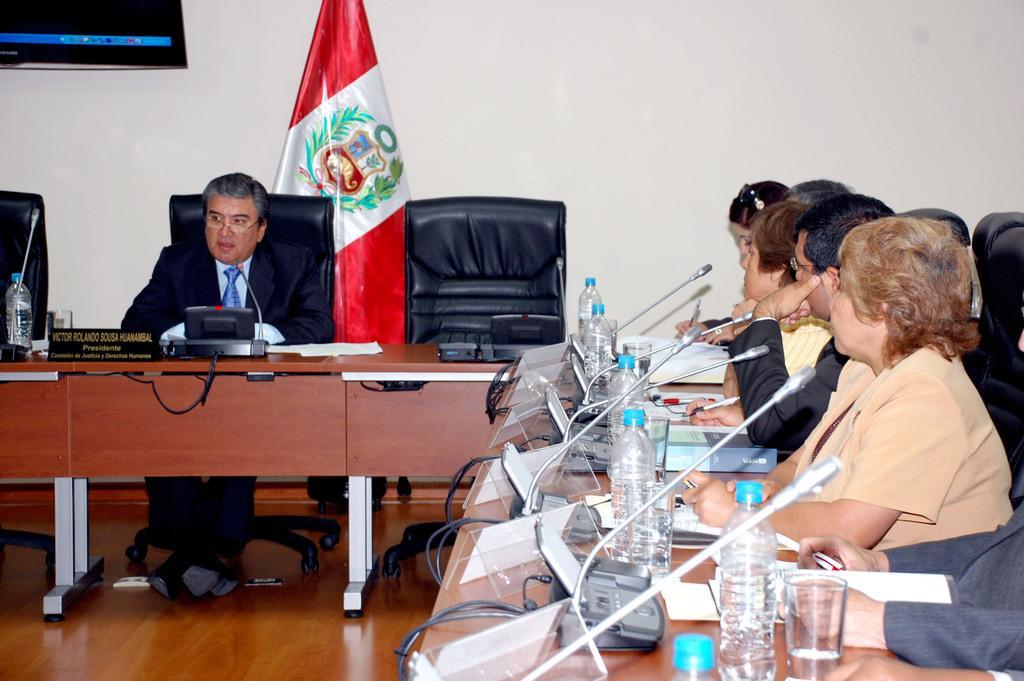Can you describe this image briefly? In this picture we can see some people are sitting on the chair in front of them there is a table on the table we can see microphones water bottles glasses and papers and the left side we can see a table on the table we have microphone water bottle and one person is sitting on the chair back side we can see a flag. 